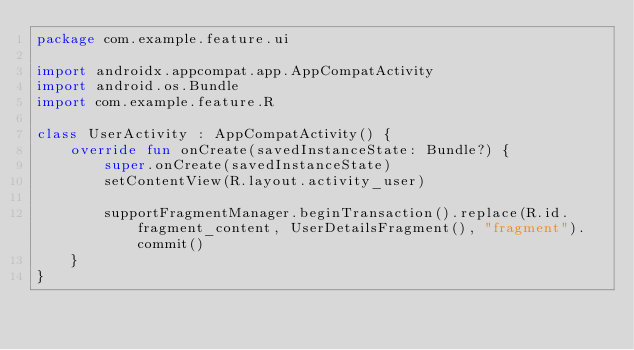<code> <loc_0><loc_0><loc_500><loc_500><_Kotlin_>package com.example.feature.ui

import androidx.appcompat.app.AppCompatActivity
import android.os.Bundle
import com.example.feature.R

class UserActivity : AppCompatActivity() {
    override fun onCreate(savedInstanceState: Bundle?) {
        super.onCreate(savedInstanceState)
        setContentView(R.layout.activity_user)

        supportFragmentManager.beginTransaction().replace(R.id.fragment_content, UserDetailsFragment(), "fragment").commit()
    }
}</code> 